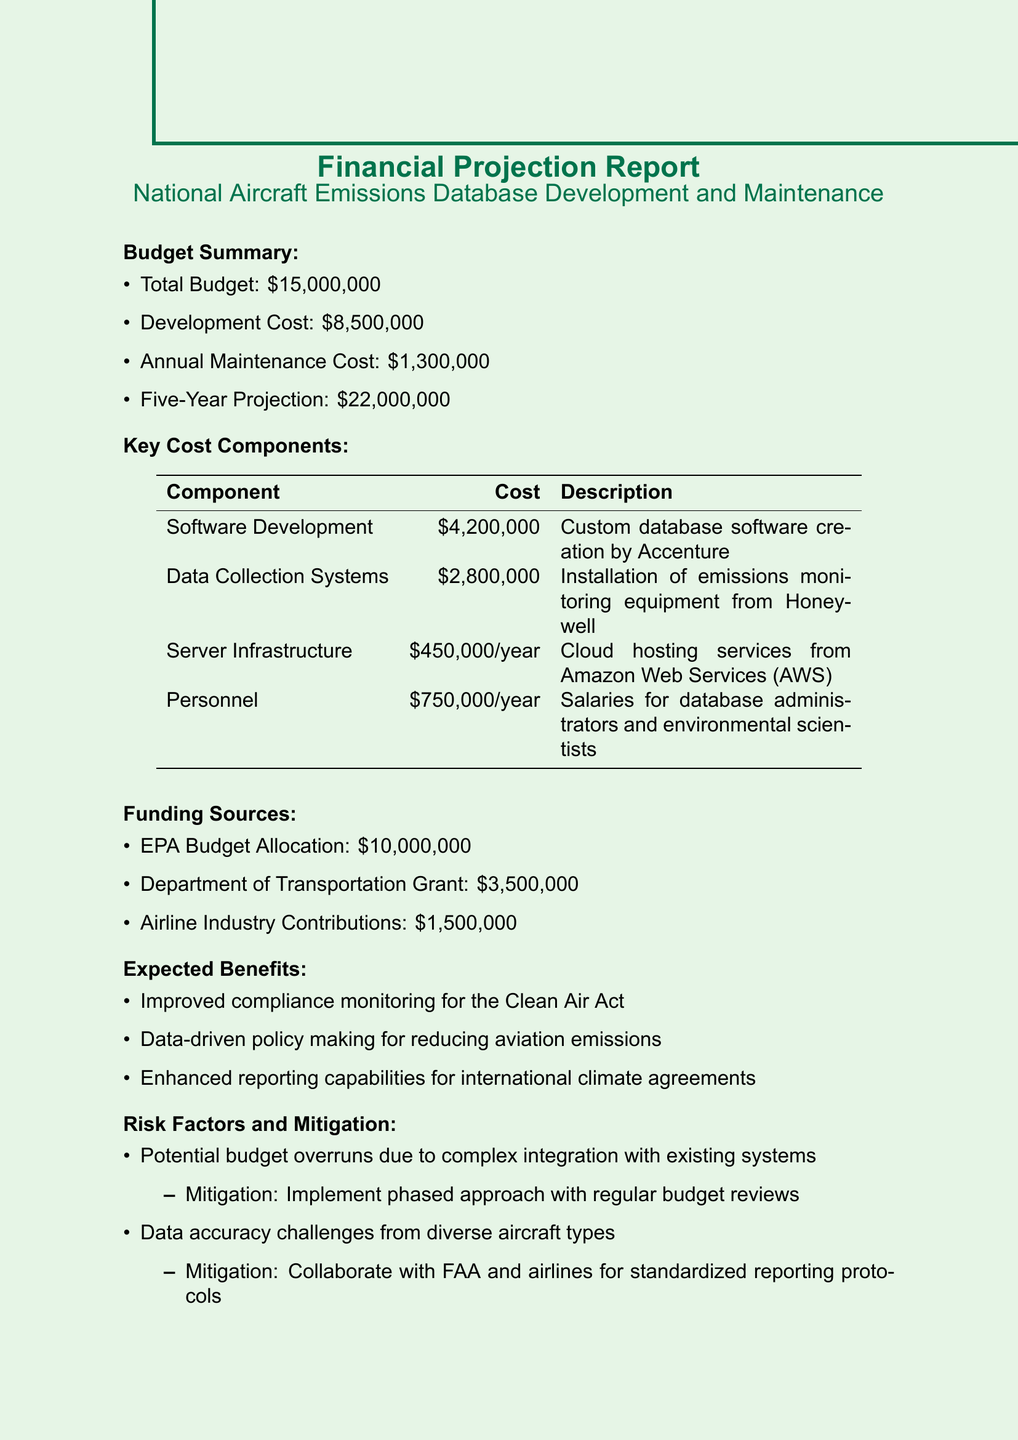What is the total budget? The total budget is provided in the budget summary section of the document, which states that the total budget is $15,000,000.
Answer: $15,000,000 What is the cost of software development? The cost of software development is listed under key cost components, showing that it amounts to $4,200,000.
Answer: $4,200,000 What is the annual maintenance cost? The annual maintenance cost can be found in the budget summary, indicating that it is $1,300,000.
Answer: $1,300,000 How much funding is allocated from the EPA budget? The EPA budget allocation amount is specified in the funding sources as $10,000,000.
Answer: $10,000,000 Which company is responsible for the data collection systems? The document mentions that Honeywell is the company responsible for installing emissions monitoring equipment under the data collection systems.
Answer: Honeywell What are the expected benefits of the database? The document lists the expected benefits, including improved compliance monitoring and data-driven policy making.
Answer: Improved compliance monitoring for the Clean Air Act What is the projected cost over five years? The five-year projection for the total cost of the project is stated in the budget summary as $22,000,000.
Answer: $22,000,000 What is a potential risk factor mentioned in the document? The risk factors section of the document points out that a potential risk factor includes budget overruns due to complex integration with existing systems.
Answer: Potential budget overruns due to complex integration with existing systems How much will personnel cost annually? The document specifies that salaries for database administrators and environmental scientists, categorized under personnel, will cost $750,000 annually.
Answer: $750,000 